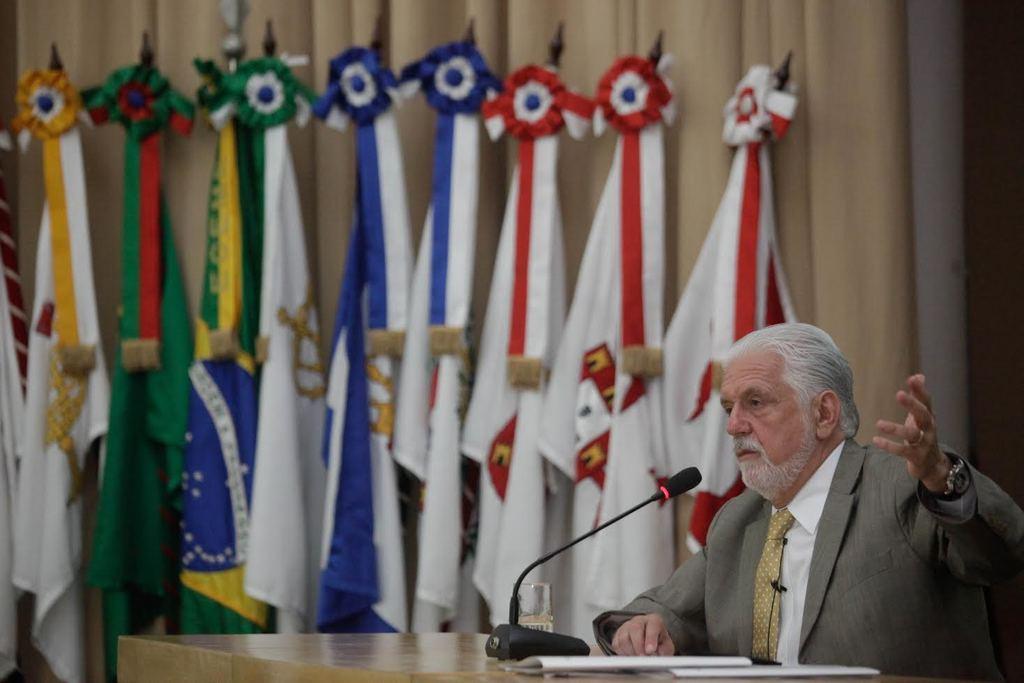Could you give a brief overview of what you see in this image? In this image in the center there is a table, on the table there are papers and there is a glass and there is a mic. On the left side there is a man sitting. In the background there are flags and there is a curtain which is cream in colour. 